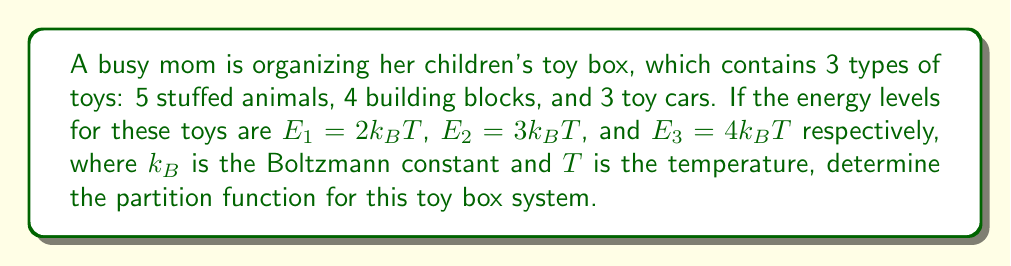Solve this math problem. To solve this problem, we'll follow these steps:

1) The partition function $Z$ for a system with multiple energy levels is given by:

   $$Z = \sum_i g_i e^{-\beta E_i}$$

   where $g_i$ is the degeneracy (number of states) for energy level $E_i$, and $\beta = \frac{1}{k_BT}$.

2) In this case, we have:
   - $g_1 = 5$ (stuffed animals), $E_1 = 2k_BT$
   - $g_2 = 4$ (building blocks), $E_2 = 3k_BT$
   - $g_3 = 3$ (toy cars), $E_3 = 4k_BT$

3) Let's calculate each term:

   For stuffed animals: $5e^{-\beta(2k_BT)} = 5e^{-2} = 5e^{-2}$
   For building blocks: $4e^{-\beta(3k_BT)} = 4e^{-3} = 4e^{-3}$
   For toy cars: $3e^{-\beta(4k_BT)} = 3e^{-4} = 3e^{-4}$

4) Now, we sum these terms:

   $$Z = 5e^{-2} + 4e^{-3} + 3e^{-4}$$

This is the partition function for the toy box system.
Answer: $Z = 5e^{-2} + 4e^{-3} + 3e^{-4}$ 